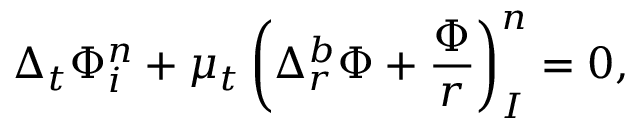Convert formula to latex. <formula><loc_0><loc_0><loc_500><loc_500>\Delta _ { t } \Phi _ { i } ^ { n } + \mu _ { t } \left ( \Delta _ { r } ^ { b } \Phi + \frac { \Phi } { r } \right ) _ { I } ^ { n } = 0 ,</formula> 